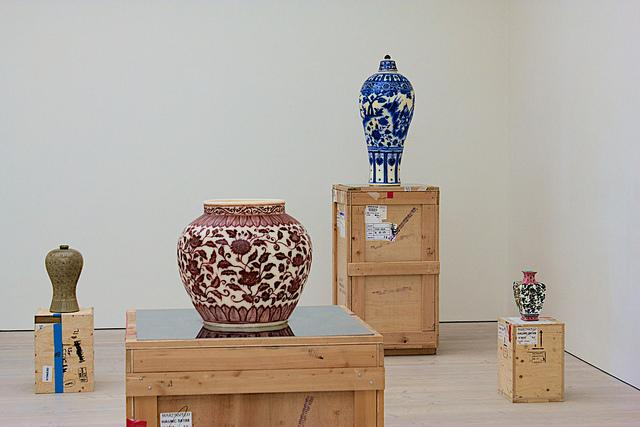What is the main color of the Chinese vase on the center right? Please explain your reasoning. blue. The colours of the vase are blue and white. 